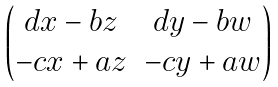<formula> <loc_0><loc_0><loc_500><loc_500>\begin{pmatrix} d x - b z & d y - b w \\ - c x + a z & - c y + a w \end{pmatrix}</formula> 